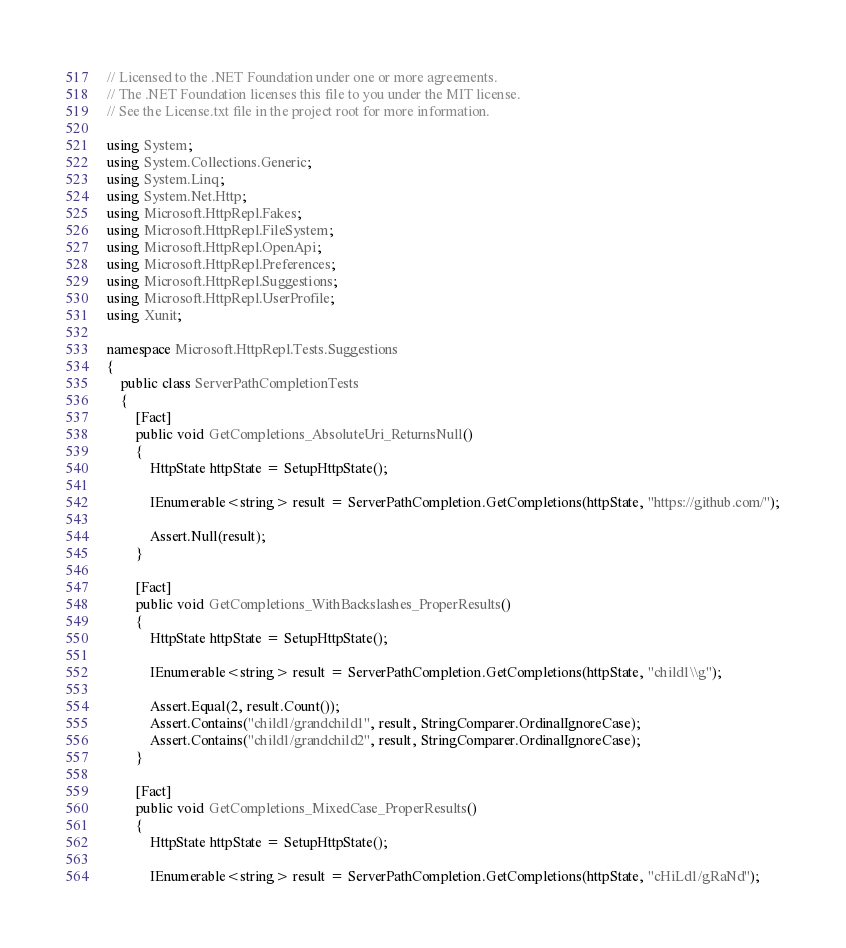Convert code to text. <code><loc_0><loc_0><loc_500><loc_500><_C#_>// Licensed to the .NET Foundation under one or more agreements.
// The .NET Foundation licenses this file to you under the MIT license.
// See the License.txt file in the project root for more information.

using System;
using System.Collections.Generic;
using System.Linq;
using System.Net.Http;
using Microsoft.HttpRepl.Fakes;
using Microsoft.HttpRepl.FileSystem;
using Microsoft.HttpRepl.OpenApi;
using Microsoft.HttpRepl.Preferences;
using Microsoft.HttpRepl.Suggestions;
using Microsoft.HttpRepl.UserProfile;
using Xunit;

namespace Microsoft.HttpRepl.Tests.Suggestions
{
    public class ServerPathCompletionTests
    {
        [Fact]
        public void GetCompletions_AbsoluteUri_ReturnsNull()
        {
            HttpState httpState = SetupHttpState();

            IEnumerable<string> result = ServerPathCompletion.GetCompletions(httpState, "https://github.com/");

            Assert.Null(result);
        }

        [Fact]
        public void GetCompletions_WithBackslashes_ProperResults()
        {
            HttpState httpState = SetupHttpState();

            IEnumerable<string> result = ServerPathCompletion.GetCompletions(httpState, "child1\\g");

            Assert.Equal(2, result.Count());
            Assert.Contains("child1/grandchild1", result, StringComparer.OrdinalIgnoreCase);
            Assert.Contains("child1/grandchild2", result, StringComparer.OrdinalIgnoreCase);
        }

        [Fact]
        public void GetCompletions_MixedCase_ProperResults()
        {
            HttpState httpState = SetupHttpState();

            IEnumerable<string> result = ServerPathCompletion.GetCompletions(httpState, "cHiLd1/gRaNd");
</code> 